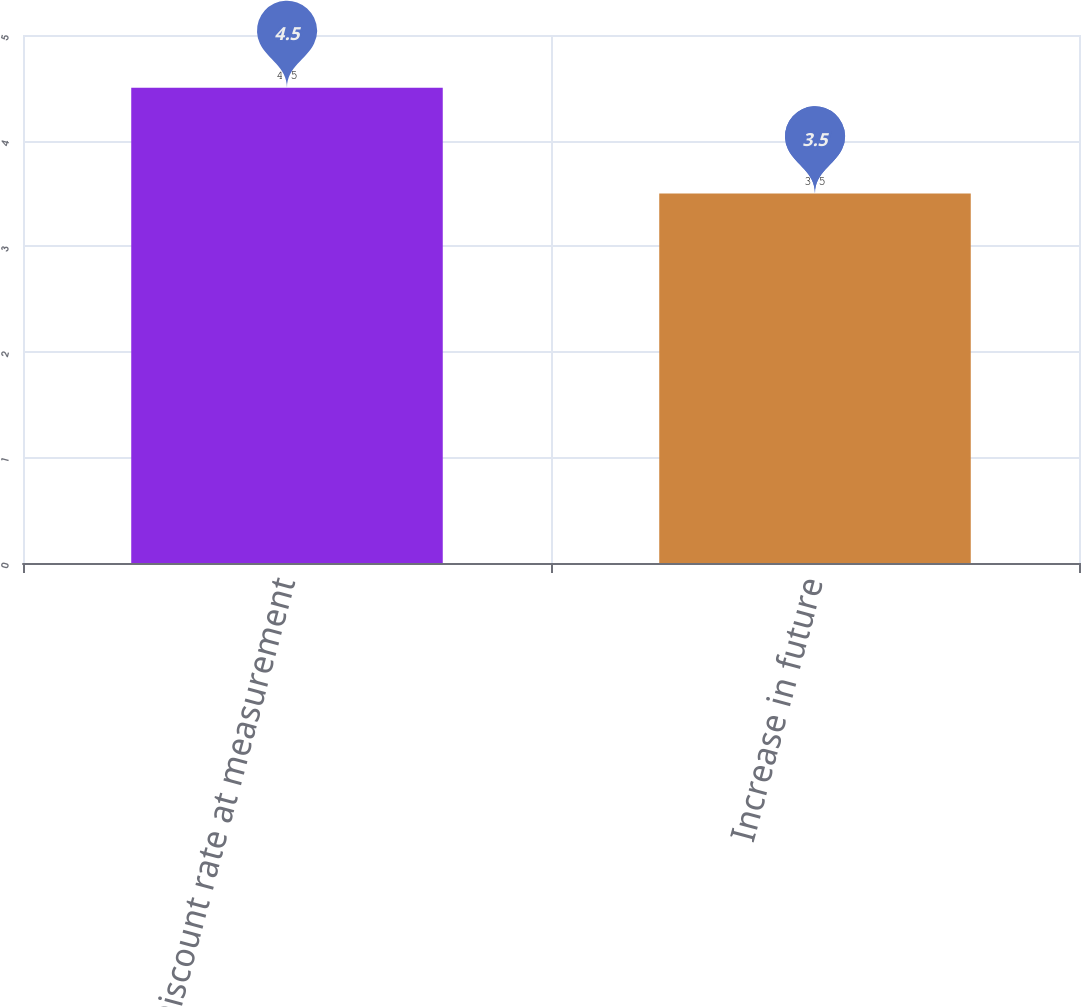Convert chart. <chart><loc_0><loc_0><loc_500><loc_500><bar_chart><fcel>Discount rate at measurement<fcel>Increase in future<nl><fcel>4.5<fcel>3.5<nl></chart> 